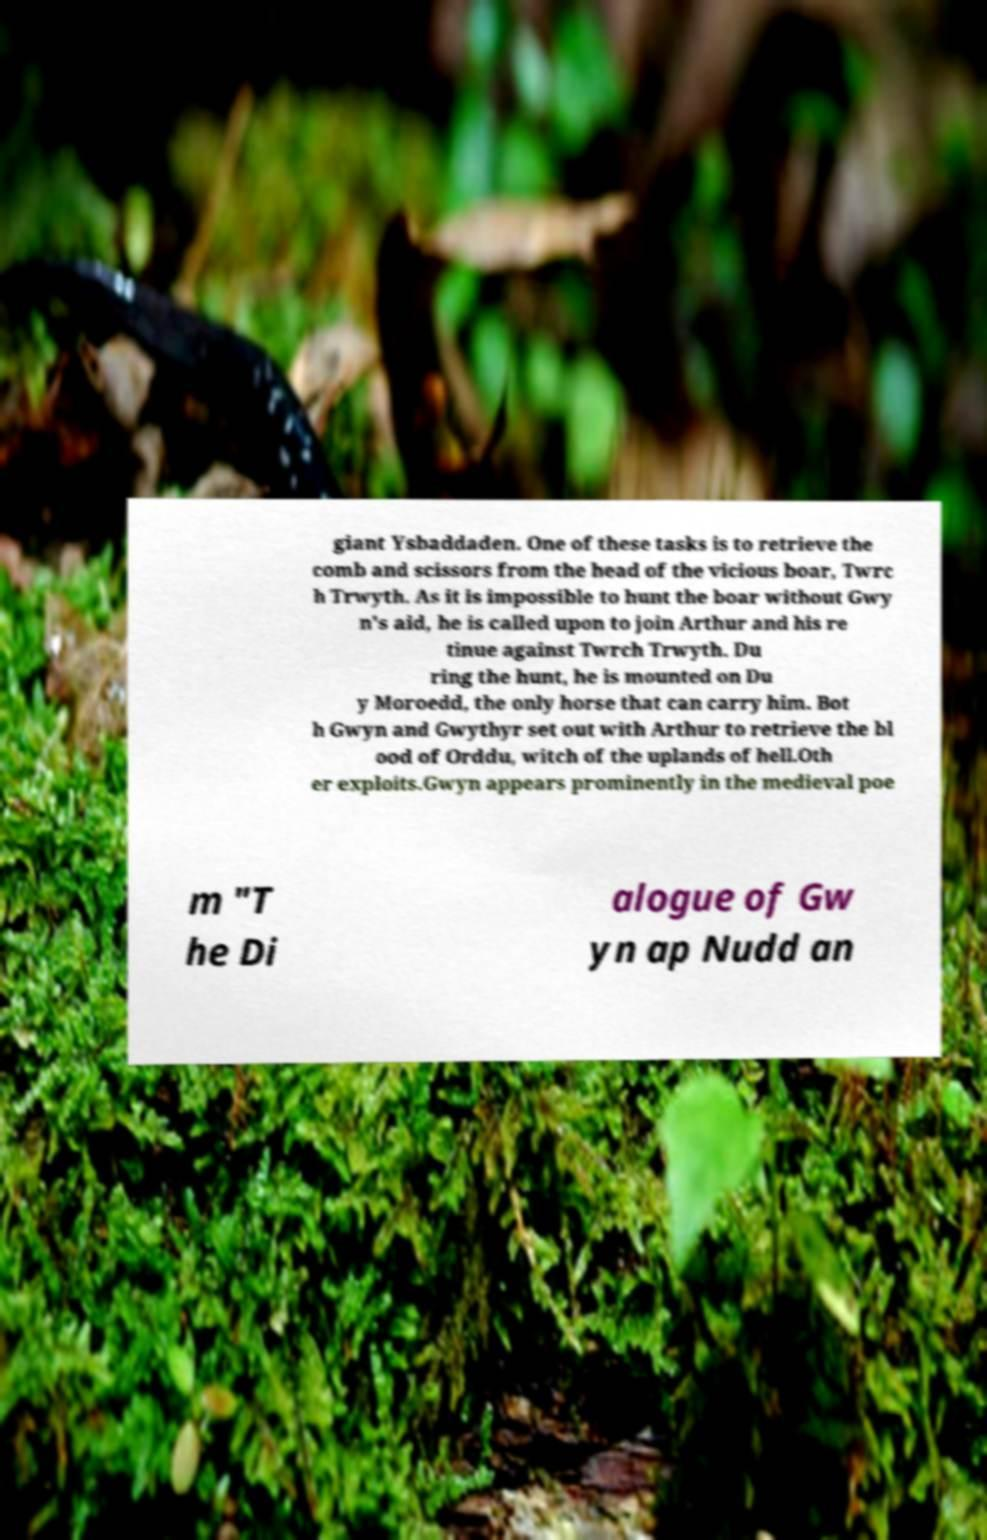I need the written content from this picture converted into text. Can you do that? giant Ysbaddaden. One of these tasks is to retrieve the comb and scissors from the head of the vicious boar, Twrc h Trwyth. As it is impossible to hunt the boar without Gwy n's aid, he is called upon to join Arthur and his re tinue against Twrch Trwyth. Du ring the hunt, he is mounted on Du y Moroedd, the only horse that can carry him. Bot h Gwyn and Gwythyr set out with Arthur to retrieve the bl ood of Orddu, witch of the uplands of hell.Oth er exploits.Gwyn appears prominently in the medieval poe m "T he Di alogue of Gw yn ap Nudd an 